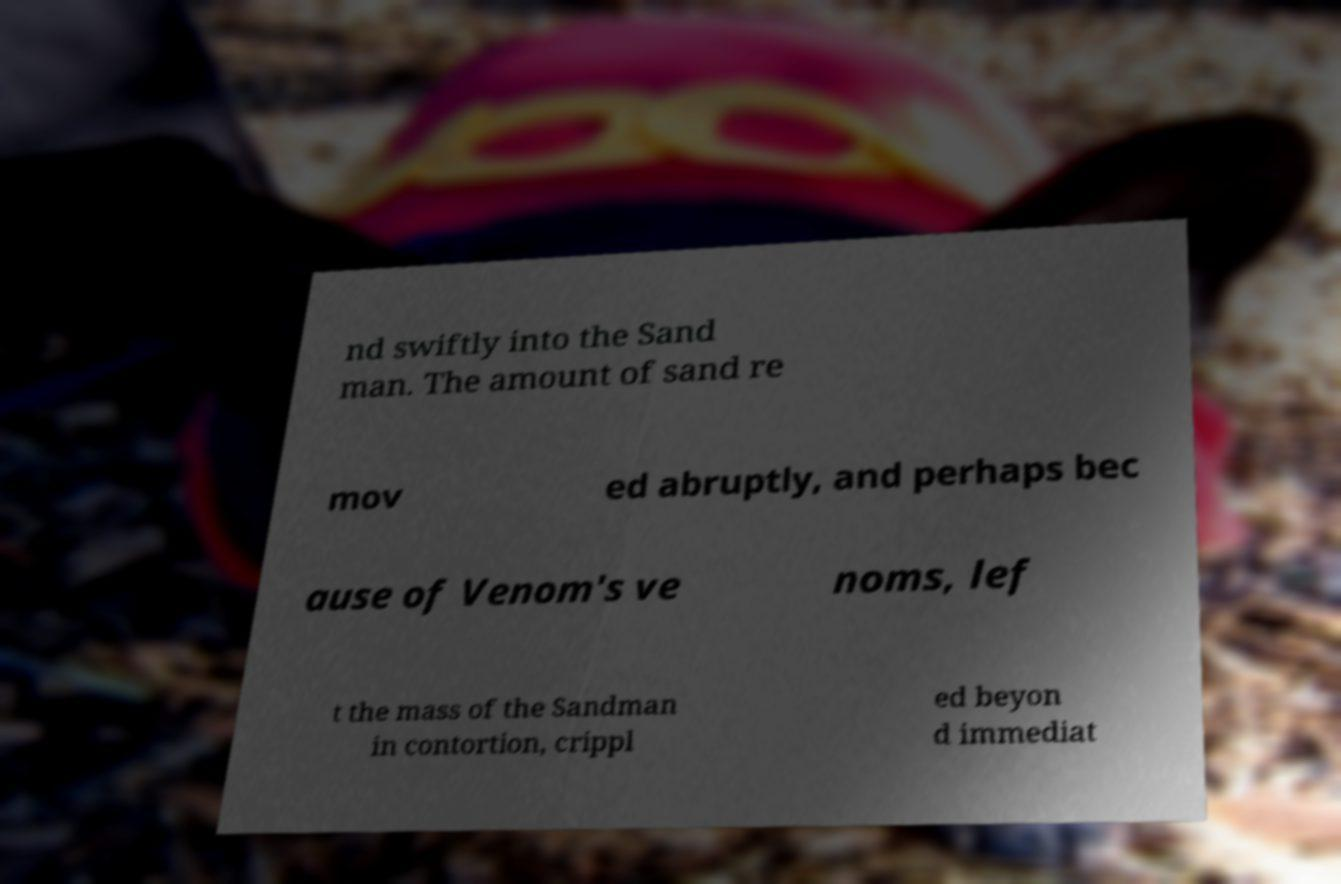Could you assist in decoding the text presented in this image and type it out clearly? nd swiftly into the Sand man. The amount of sand re mov ed abruptly, and perhaps bec ause of Venom's ve noms, lef t the mass of the Sandman in contortion, crippl ed beyon d immediat 